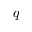Convert formula to latex. <formula><loc_0><loc_0><loc_500><loc_500>q</formula> 